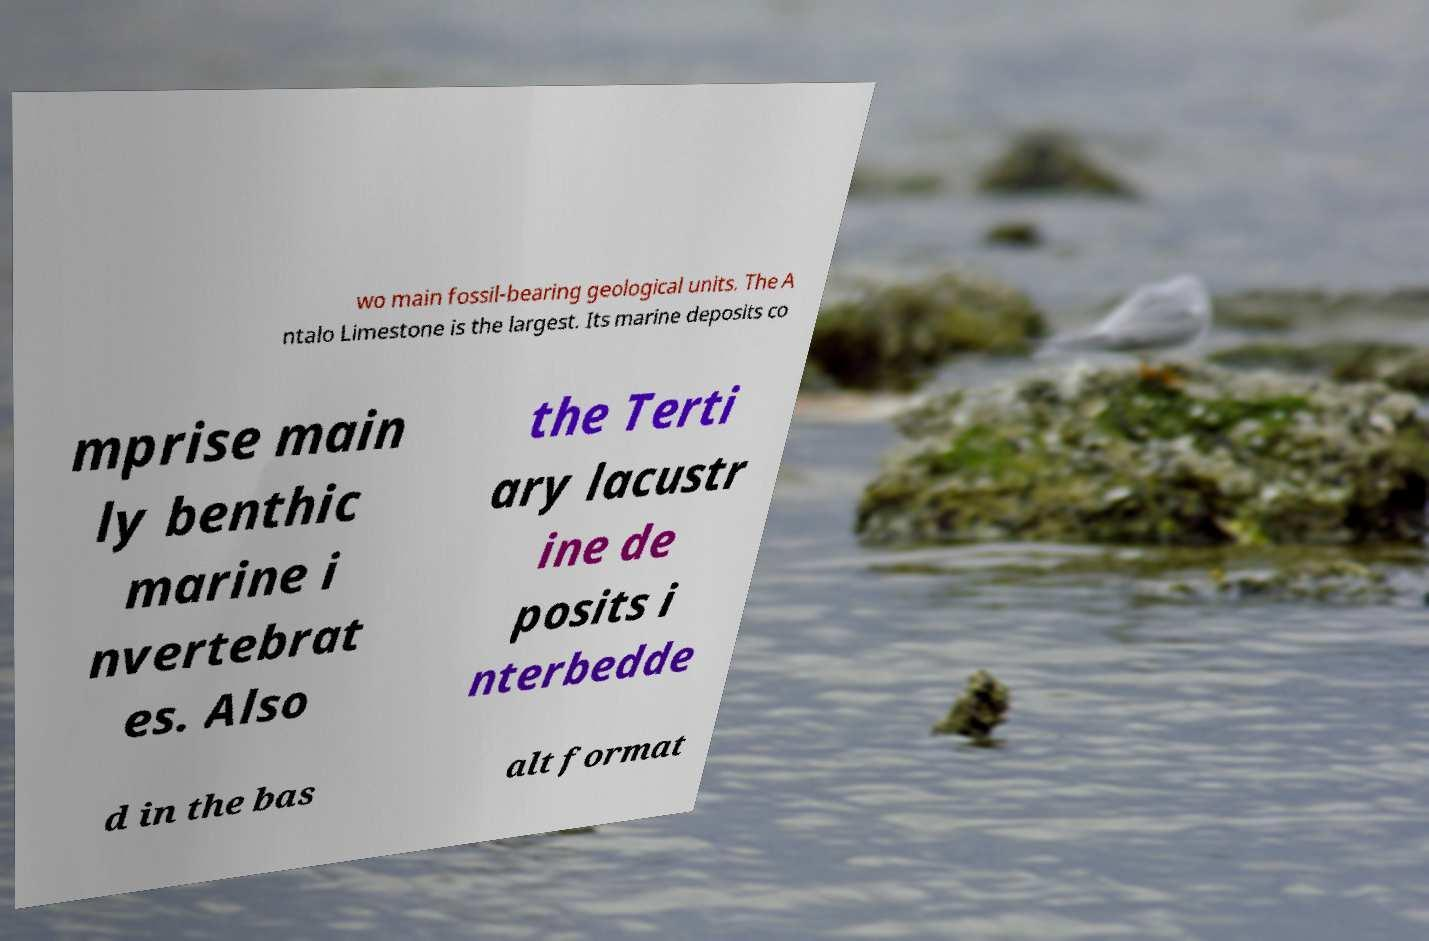Could you extract and type out the text from this image? wo main fossil-bearing geological units. The A ntalo Limestone is the largest. Its marine deposits co mprise main ly benthic marine i nvertebrat es. Also the Terti ary lacustr ine de posits i nterbedde d in the bas alt format 